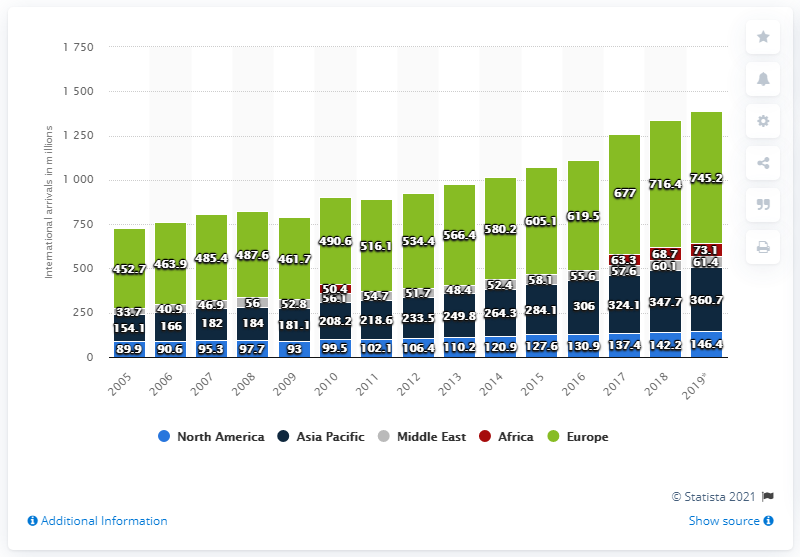Outline some significant characteristics in this image. In 2019, there were 61.4 million international tourist arrivals in the Middle East. In 2019, there were 146,400 international tourist arrivals in North America. 